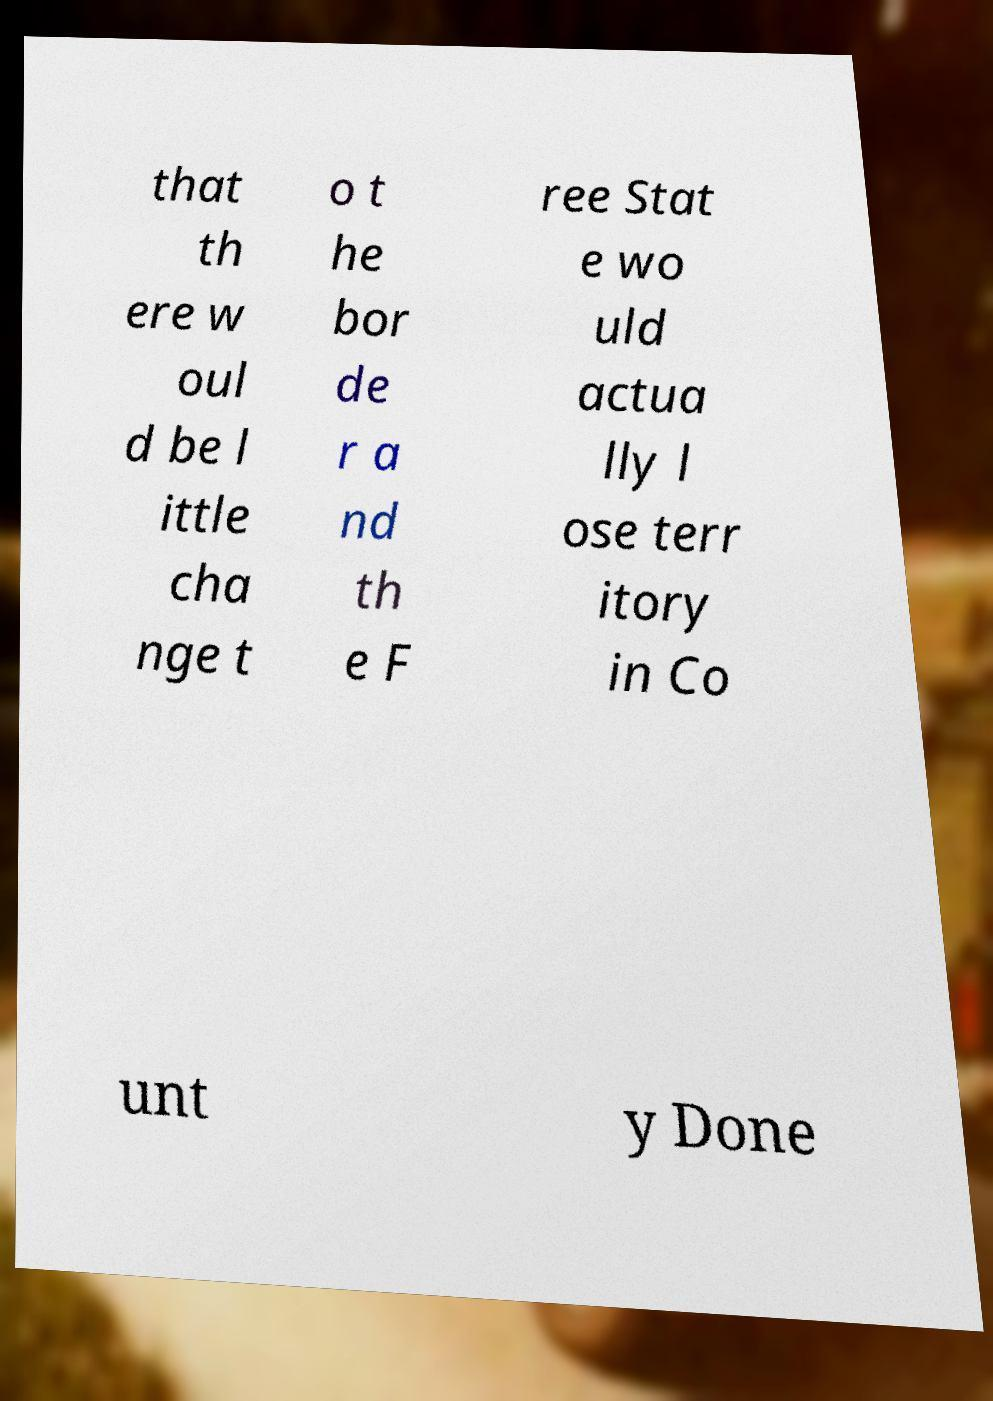What messages or text are displayed in this image? I need them in a readable, typed format. that th ere w oul d be l ittle cha nge t o t he bor de r a nd th e F ree Stat e wo uld actua lly l ose terr itory in Co unt y Done 